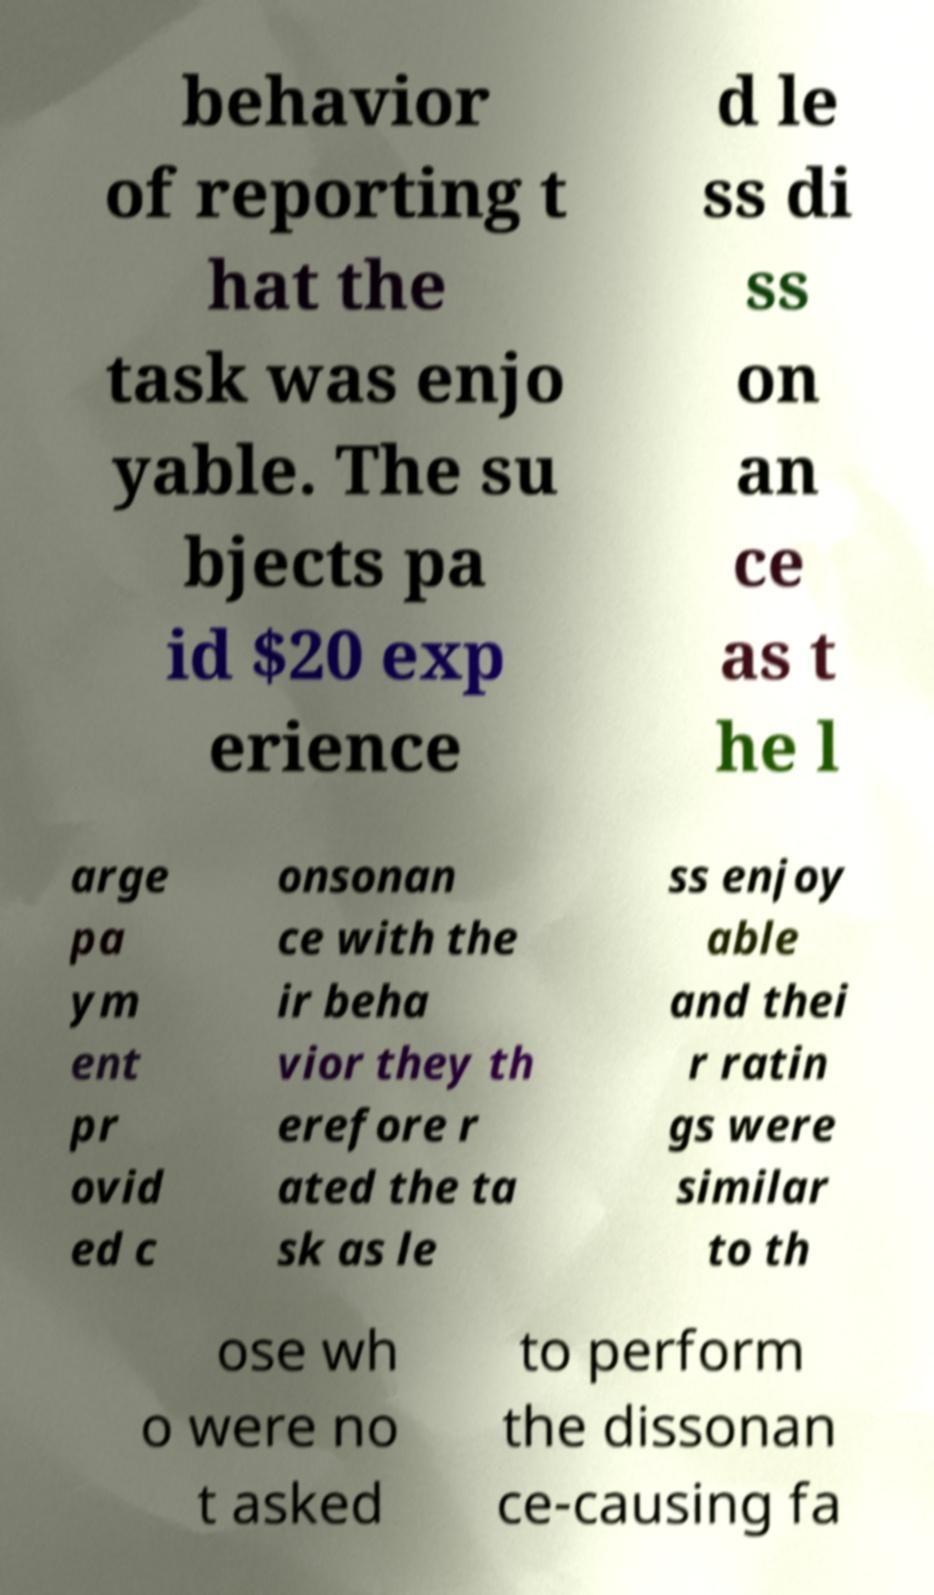Can you read and provide the text displayed in the image?This photo seems to have some interesting text. Can you extract and type it out for me? behavior of reporting t hat the task was enjo yable. The su bjects pa id $20 exp erience d le ss di ss on an ce as t he l arge pa ym ent pr ovid ed c onsonan ce with the ir beha vior they th erefore r ated the ta sk as le ss enjoy able and thei r ratin gs were similar to th ose wh o were no t asked to perform the dissonan ce-causing fa 